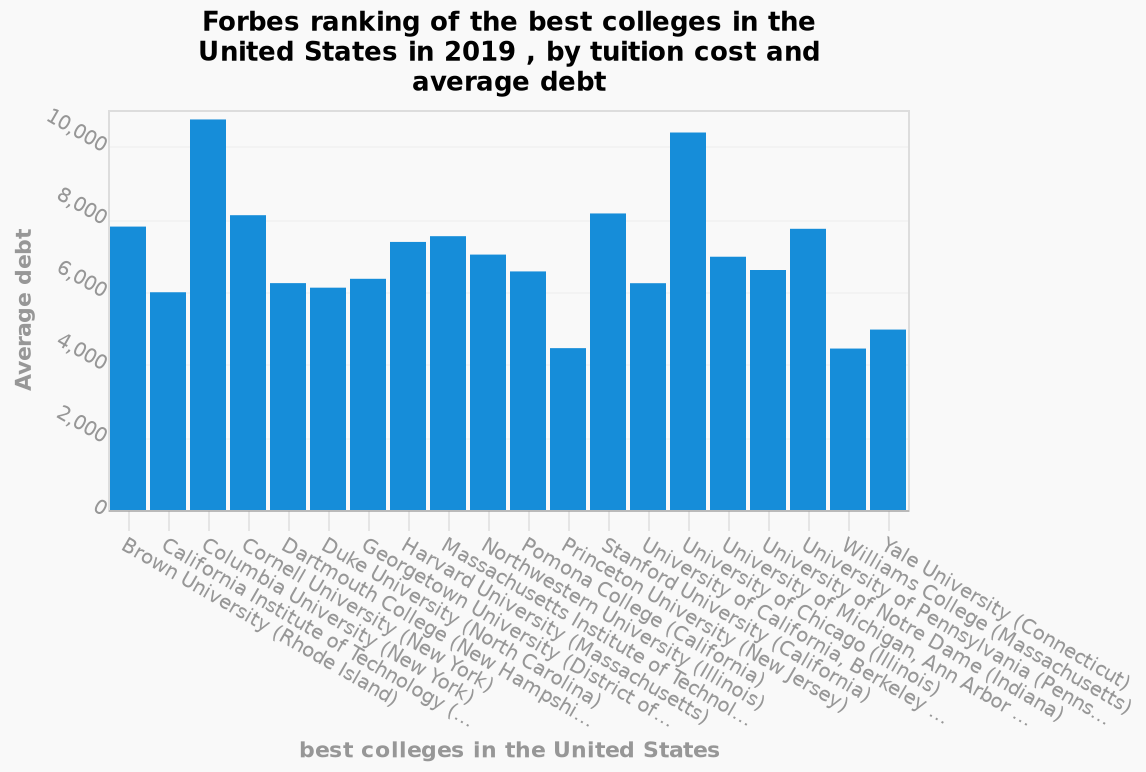<image>
please describe the details of the chart This is a bar chart named Forbes ranking of the best colleges in the United States in 2019 , by tuition cost and average debt. There is a linear scale with a minimum of 0 and a maximum of 10,000 on the y-axis, labeled Average debt. The x-axis shows best colleges in the United States using a categorical scale starting at Brown University (Rhode Island) and ending at Yale University (Connecticut). What is shown on the x-axis of the bar chart? The x-axis of the bar chart shows the best colleges in the United States. Can you name the colleges that exceed 10k debt and also those below 6k debt? The colleges that exceed 10k debt are Columbia NY and Chicago Illinois. The colleges below 6k debt are Yale Connecticut, Williams College Massachusetts, and Princeton New Jersey. 